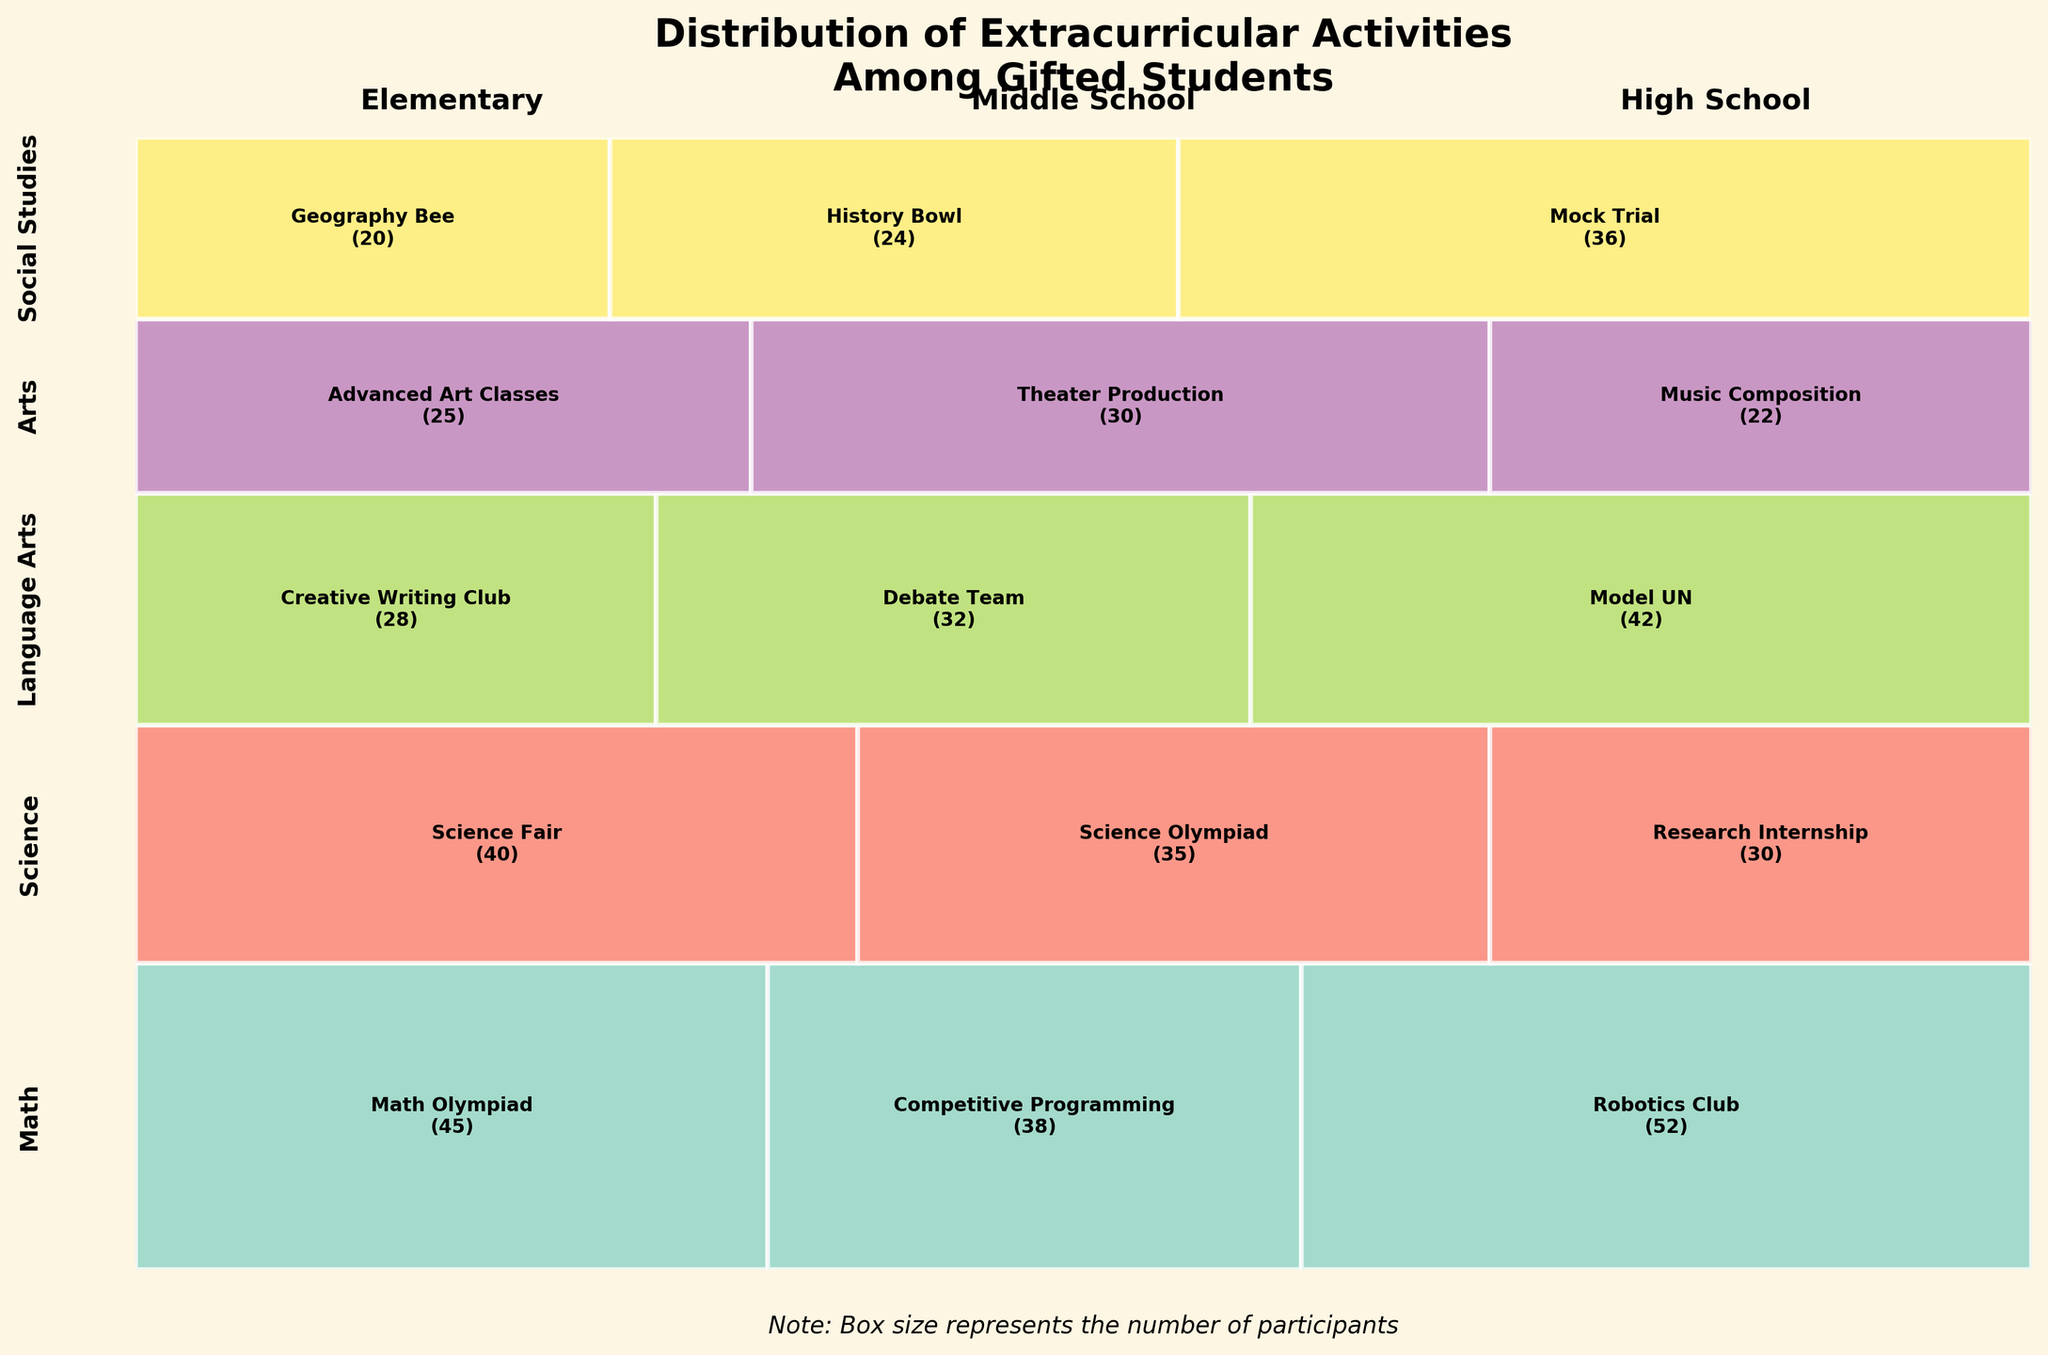what is the extracurricular activity for high school students who prefer Science? Locate the Science section of the plot, then find the part representing high school students. The label will indicate the extracurricular activity.
Answer: Research Internship which subject has the highest participation in extracurricular activities for elementary grade? Find the sections of the plot representing elementary grade for each subject and compare the sizes. The largest section determines the highest participation.
Answer: Math how many middle school students participate in Theater Production? Find the middle school section within the Arts part of the plot and read the number inside the Theater Production rectangle.
Answer: 30 what is the total number of participants in Science extracurricular activities? Sum the counts of participants in all grade levels under the Science subject (40 for elementary, 35 for middle school, 30 for high school). 40 + 35 + 30 results in 105.
Answer: 105 is the participation in Debate Team higher or lower than Model UN? Locate the sections for Debate Team and Model UN, both under Language Arts, and compare the participation numbers (Debate Team: 32, Model UN: 42).
Answer: Lower which subject has the fewest extracurricular activities listed? Count the number of different extracurricular activities under each subject's section. The one with the smallest number of activities has the fewest listed.
Answer: Arts how does the participation in Robotics Club compare to Competitive Programming? Find the sections for Robotics Club and Competitive Programming under the Math subject and compare the counts (Robotics Club: 52, Competitive Programming: 38).
Answer: Higher what is the total participation in social studies extracurricular activities across all grades? Sum the counts for elementary, middle school, and high school within the Social Studies segment (20 + 24 + 36). 20 + 24 + 36 equals 80.
Answer: 80 which grade level has the highest participation in Language Arts extracurricular activities? Examine the sections for each grade level under Language Arts and compare their sizes to find the highest.
Answer: High School 